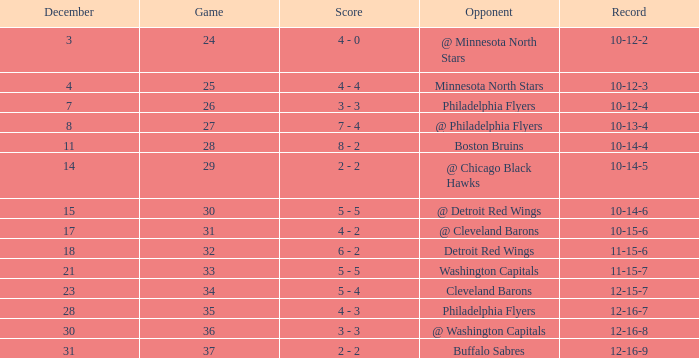What is the lowest December, when Score is "4 - 4"? 4.0. 